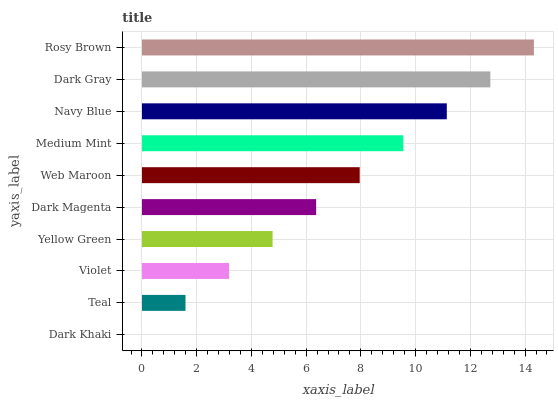Is Dark Khaki the minimum?
Answer yes or no. Yes. Is Rosy Brown the maximum?
Answer yes or no. Yes. Is Teal the minimum?
Answer yes or no. No. Is Teal the maximum?
Answer yes or no. No. Is Teal greater than Dark Khaki?
Answer yes or no. Yes. Is Dark Khaki less than Teal?
Answer yes or no. Yes. Is Dark Khaki greater than Teal?
Answer yes or no. No. Is Teal less than Dark Khaki?
Answer yes or no. No. Is Web Maroon the high median?
Answer yes or no. Yes. Is Dark Magenta the low median?
Answer yes or no. Yes. Is Yellow Green the high median?
Answer yes or no. No. Is Yellow Green the low median?
Answer yes or no. No. 